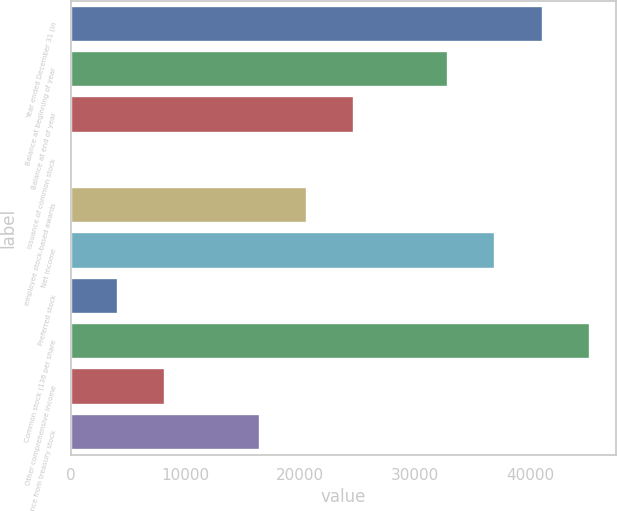<chart> <loc_0><loc_0><loc_500><loc_500><bar_chart><fcel>Year ended December 31 (in<fcel>Balance at beginning of year<fcel>Balance at end of year<fcel>Issuance of common stock<fcel>employee stock-based awards<fcel>Net income<fcel>Preferred stock<fcel>Common stock (136 per share<fcel>Other comprehensive income<fcel>Reissuance from treasury stock<nl><fcel>41099<fcel>32890.2<fcel>24681.4<fcel>55<fcel>20577<fcel>36994.6<fcel>4159.4<fcel>45203.4<fcel>8263.8<fcel>16472.6<nl></chart> 